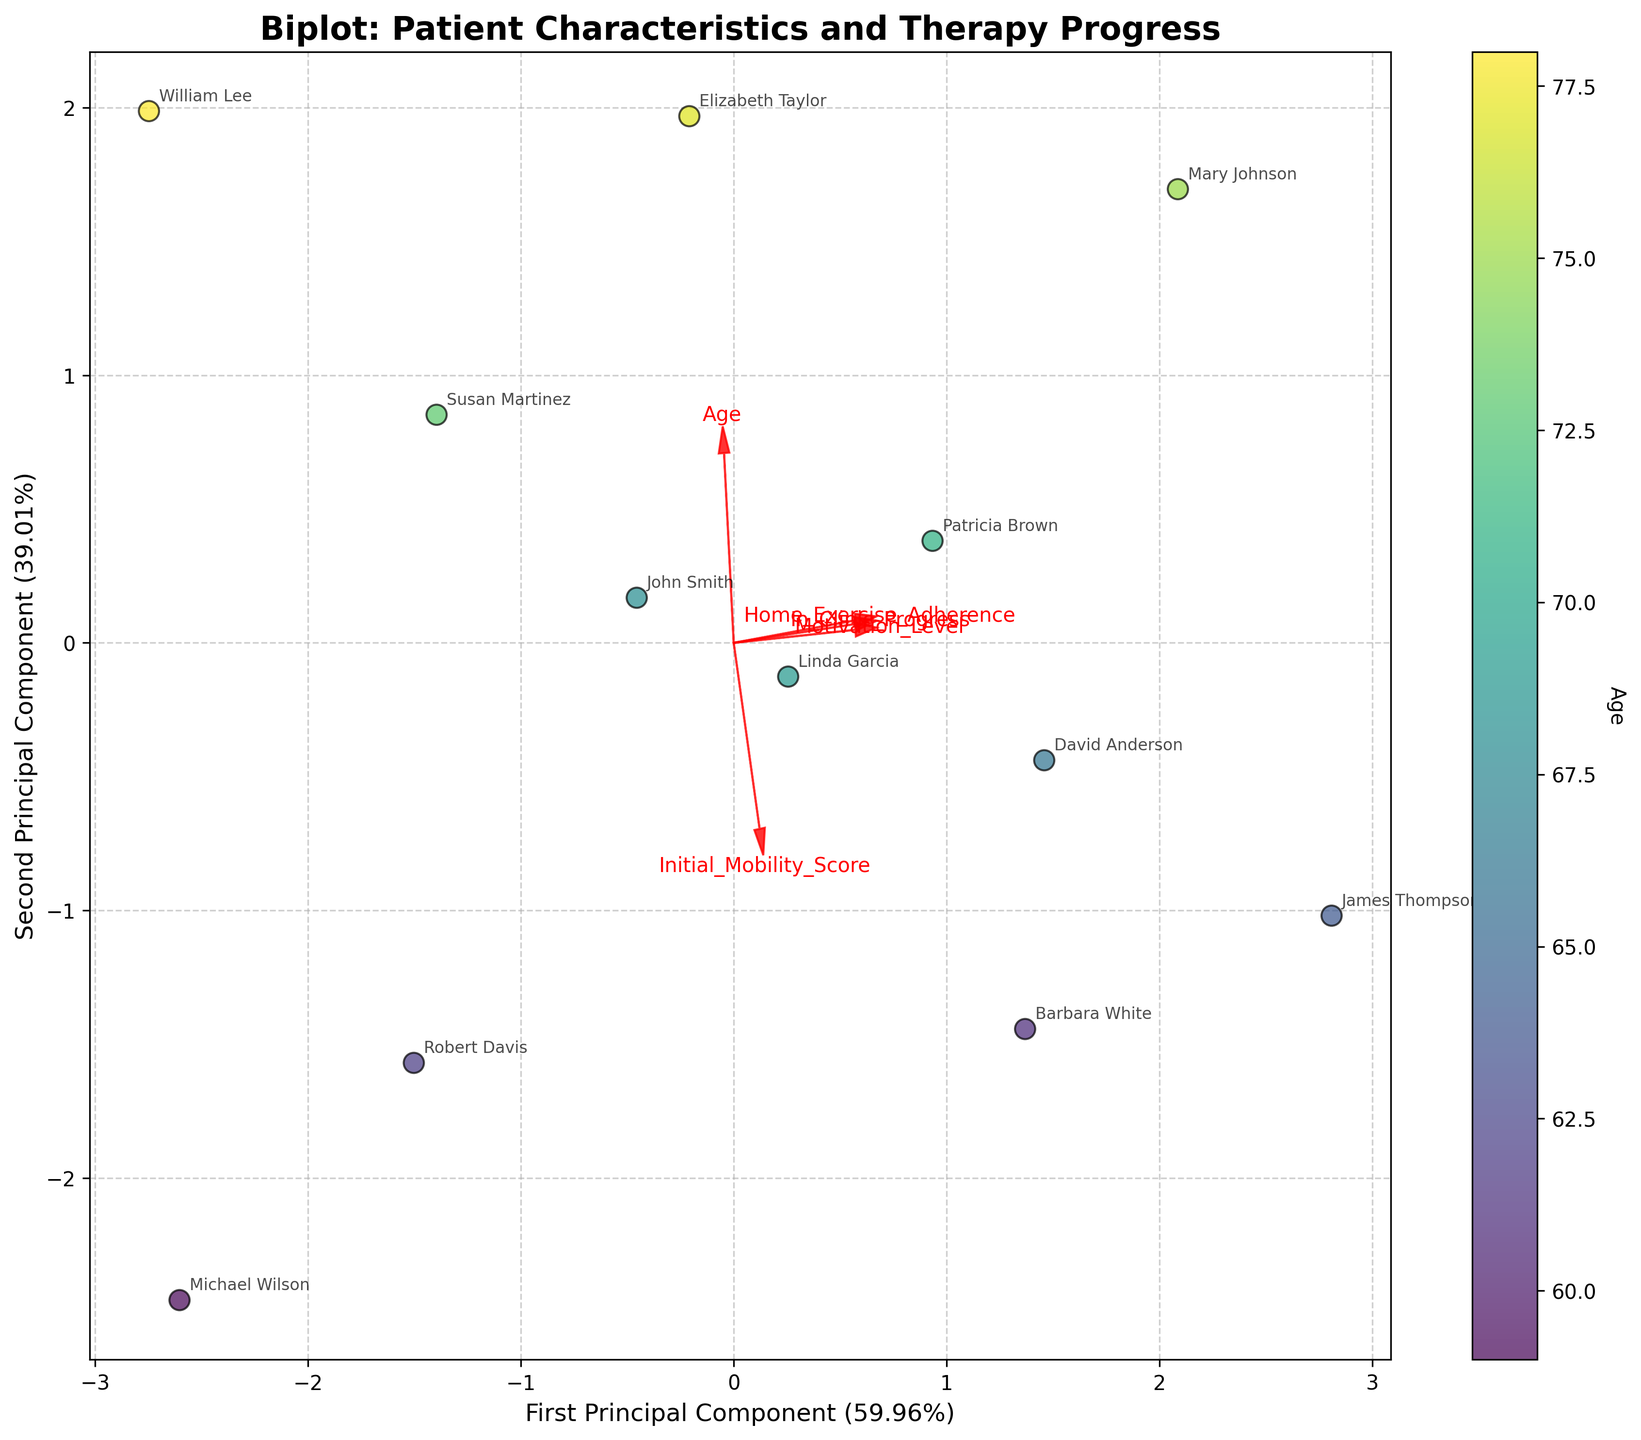How many principal components are shown in the biplot? The biplot displays two principal components. This can be deduced from the labels on the x-axis and y-axis, which indicate the 'First Principal Component' and 'Second Principal Component,' respectively.
Answer: Two What is the title of the biplot? The title of the biplot is written at the top of the figure and it reads 'Biplot: Patient Characteristics and Therapy Progress.'
Answer: Biplot: Patient Characteristics and Therapy Progress Which variable is indicated by the color gradient in the scatter plot? The variable indicating the color gradient in the scatter plot is 'Age.' This information can be verified by looking at the color bar labeled 'Age' on the right side of the plot.
Answer: Age Which two variables seem to be the most positively correlated based on the biplot arrows? The most positively correlated variables can be identified by looking at the biplot arrows. 'Initial_Mobility_Score' and 'In_Clinic_Progress' arrows point in somewhat similar directions, indicating a positive correlation.
Answer: Initial_Mobility_Score and In_Clinic_Progress Which patient has the highest adherence to home exercise programs in the biplot? To find the patient with the highest home exercise adherence, look for the arrow representing 'Home_Exercise_Adherence' and check which patient's data point is farthest along the direction of this arrow. 'James Thompson' is the patient with the highest adherence.
Answer: James Thompson Are age and motivation level positively correlated based on the biplot? Check the directions of the arrows for 'Age' and 'Motivation_Level.' If they point in similar directions, it indicates a positive correlation. The 'Age' and 'Motivation_Level' arrows are not pointing in similar directions, which suggests that they are not positively correlated.
Answer: No Which patient has the maximum progress in in-clinic therapy according to the biplot? Look for the data point farthest along the direction of the 'In_Clinic_Progress' arrow. 'James Thompson' has the maximum in-clinic therapy progress.
Answer: James Thompson Are home exercise adherence and initial mobility score strongly related based on the biplot? Analyze the directions of 'Home_Exercise_Adherence' and 'Initial_Mobility_Score' arrows. If they point in similar directions, they are positively correlated. Otherwise, they aren't strongly related. The two arrows do not point in similar directions, indicating they are not strongly related.
Answer: No 